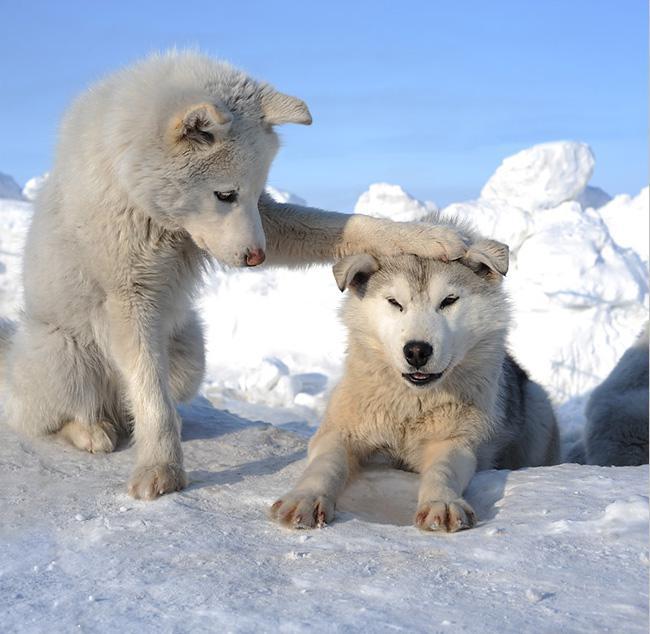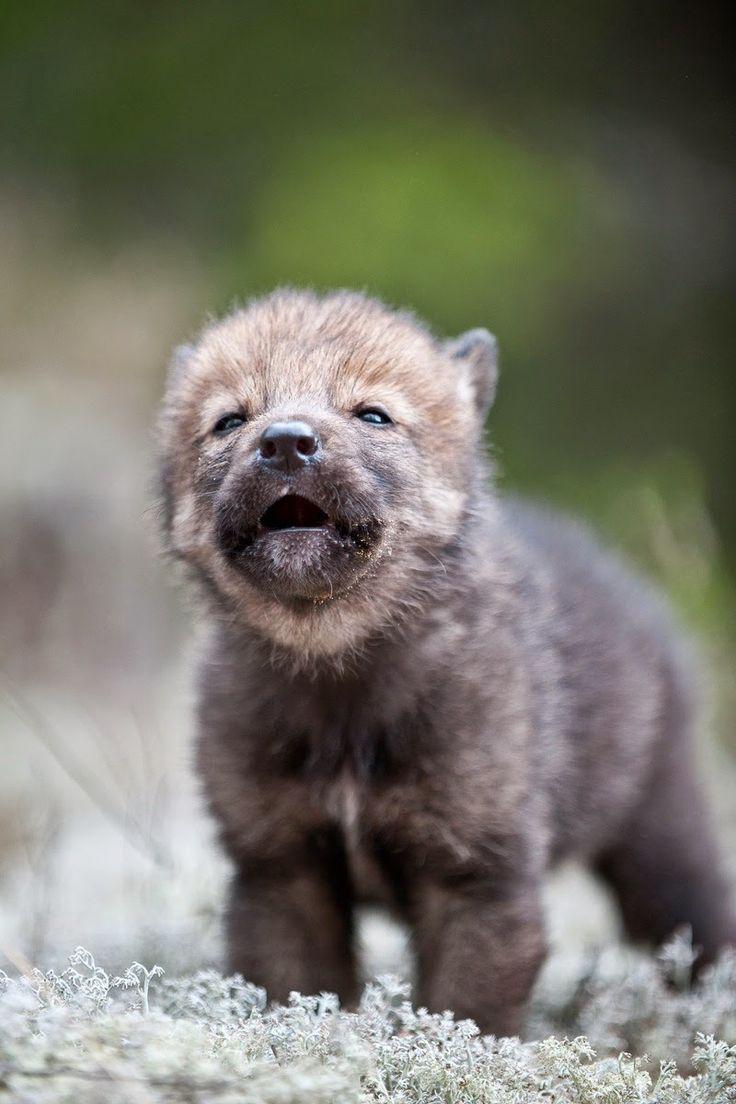The first image is the image on the left, the second image is the image on the right. Evaluate the accuracy of this statement regarding the images: "Left image contains two dogs and right image contains one dog.". Is it true? Answer yes or no. Yes. The first image is the image on the left, the second image is the image on the right. Assess this claim about the two images: "Fencing is in the background of one image.". Correct or not? Answer yes or no. No. 